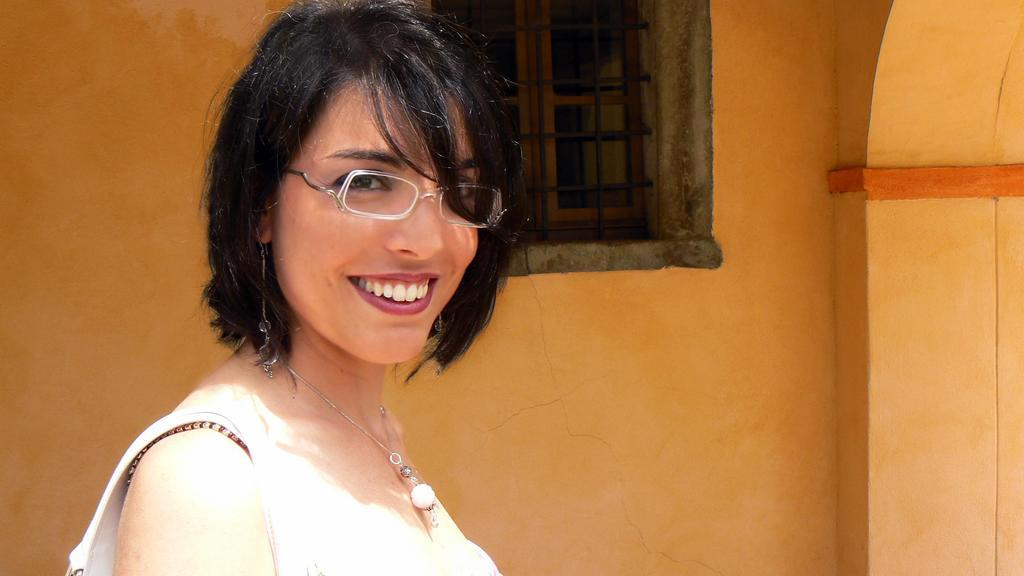Where was the image taken? The image is taken outdoors. What can be seen in the background of the image? There is a wall with a window in the background. Can you describe the woman in the image? The woman is on the left side of the image and has a smiling face. How many lizards are climbing on the boot in the image? There are no lizards or boots present in the image. 